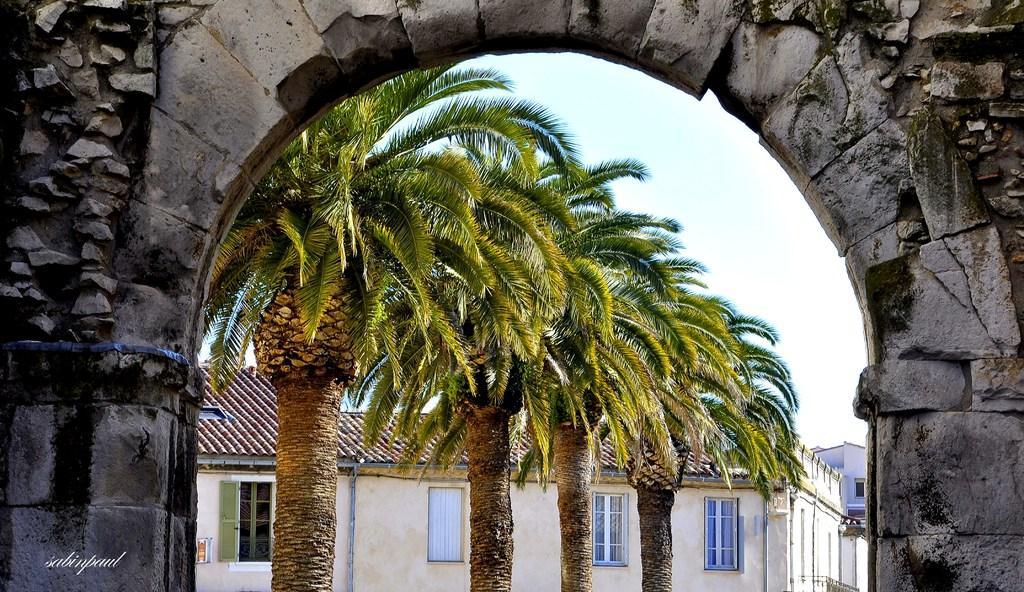How would you summarize this image in a sentence or two? In this image we can see the stone arch, trees, houses and the sky in the background. Here we can see the watermark on the bottom left side of the image. 